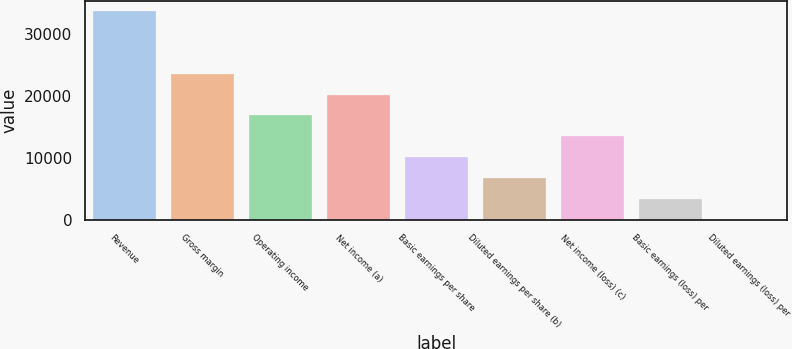<chart> <loc_0><loc_0><loc_500><loc_500><bar_chart><fcel>Revenue<fcel>Gross margin<fcel>Operating income<fcel>Net income (a)<fcel>Basic earnings per share<fcel>Diluted earnings per share (b)<fcel>Net income (loss) (c)<fcel>Basic earnings (loss) per<fcel>Diluted earnings (loss) per<nl><fcel>33717<fcel>23602.3<fcel>16859.1<fcel>20230.7<fcel>10115.9<fcel>6744.32<fcel>13487.5<fcel>3372.73<fcel>1.14<nl></chart> 